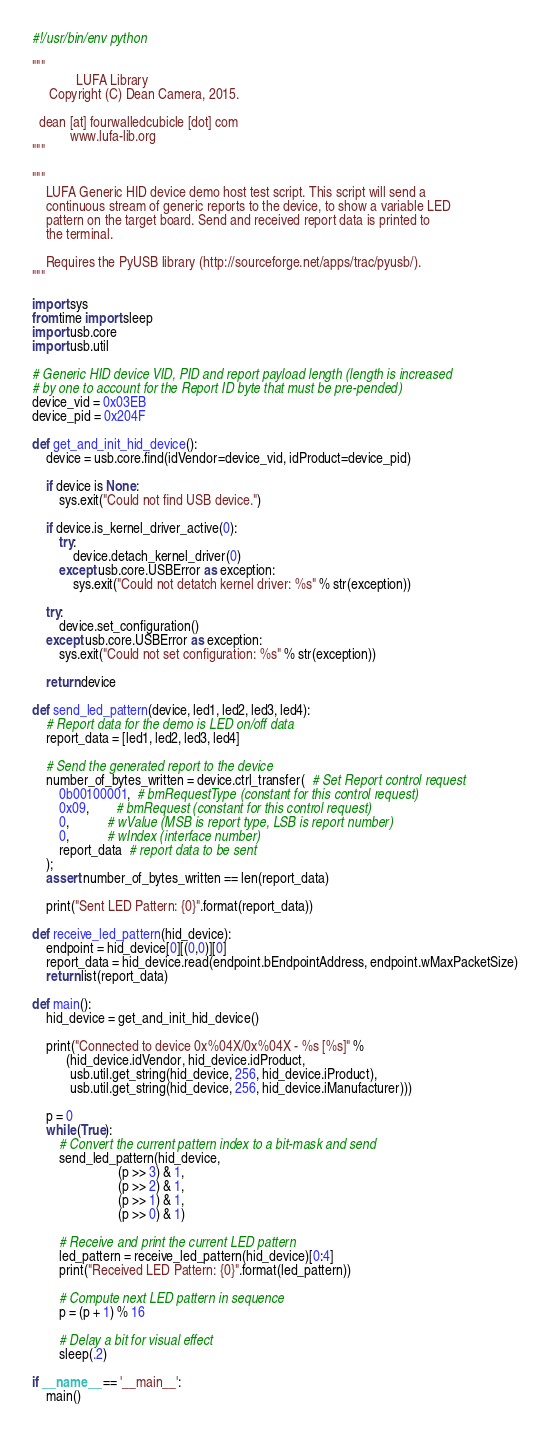Convert code to text. <code><loc_0><loc_0><loc_500><loc_500><_Python_>#!/usr/bin/env python

"""
             LUFA Library
     Copyright (C) Dean Camera, 2015.

  dean [at] fourwalledcubicle [dot] com
           www.lufa-lib.org
"""

"""
    LUFA Generic HID device demo host test script. This script will send a
    continuous stream of generic reports to the device, to show a variable LED
    pattern on the target board. Send and received report data is printed to
    the terminal.

    Requires the PyUSB library (http://sourceforge.net/apps/trac/pyusb/).
"""

import sys
from time import sleep
import usb.core
import usb.util

# Generic HID device VID, PID and report payload length (length is increased
# by one to account for the Report ID byte that must be pre-pended)
device_vid = 0x03EB
device_pid = 0x204F

def get_and_init_hid_device():
    device = usb.core.find(idVendor=device_vid, idProduct=device_pid)

    if device is None:
        sys.exit("Could not find USB device.")

    if device.is_kernel_driver_active(0):
        try:
            device.detach_kernel_driver(0)
        except usb.core.USBError as exception:
            sys.exit("Could not detatch kernel driver: %s" % str(exception))

    try:
        device.set_configuration()
    except usb.core.USBError as exception:
        sys.exit("Could not set configuration: %s" % str(exception))

    return device

def send_led_pattern(device, led1, led2, led3, led4):
    # Report data for the demo is LED on/off data
    report_data = [led1, led2, led3, led4]

    # Send the generated report to the device
    number_of_bytes_written = device.ctrl_transfer(  # Set Report control request
        0b00100001,  # bmRequestType (constant for this control request)
        0x09,        # bmRequest (constant for this control request)
        0,           # wValue (MSB is report type, LSB is report number)
        0,           # wIndex (interface number)
        report_data  # report data to be sent
    );
    assert number_of_bytes_written == len(report_data)

    print("Sent LED Pattern: {0}".format(report_data))

def receive_led_pattern(hid_device):
    endpoint = hid_device[0][(0,0)][0]
    report_data = hid_device.read(endpoint.bEndpointAddress, endpoint.wMaxPacketSize)
    return list(report_data)

def main():
    hid_device = get_and_init_hid_device()

    print("Connected to device 0x%04X/0x%04X - %s [%s]" %
          (hid_device.idVendor, hid_device.idProduct,
           usb.util.get_string(hid_device, 256, hid_device.iProduct),
           usb.util.get_string(hid_device, 256, hid_device.iManufacturer)))

    p = 0
    while (True):
        # Convert the current pattern index to a bit-mask and send
        send_led_pattern(hid_device,
                         (p >> 3) & 1,
                         (p >> 2) & 1,
                         (p >> 1) & 1,
                         (p >> 0) & 1)

        # Receive and print the current LED pattern
        led_pattern = receive_led_pattern(hid_device)[0:4]
        print("Received LED Pattern: {0}".format(led_pattern))

        # Compute next LED pattern in sequence
        p = (p + 1) % 16

        # Delay a bit for visual effect
        sleep(.2)

if __name__ == '__main__':
    main()
</code> 